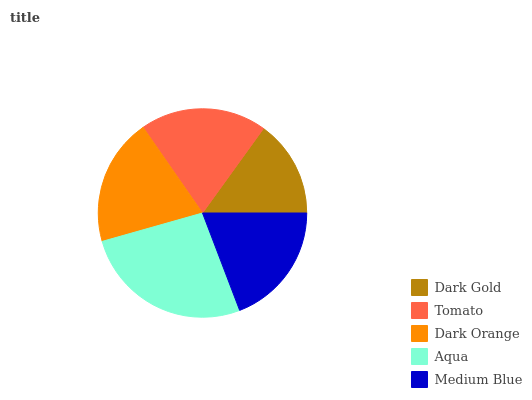Is Dark Gold the minimum?
Answer yes or no. Yes. Is Aqua the maximum?
Answer yes or no. Yes. Is Tomato the minimum?
Answer yes or no. No. Is Tomato the maximum?
Answer yes or no. No. Is Tomato greater than Dark Gold?
Answer yes or no. Yes. Is Dark Gold less than Tomato?
Answer yes or no. Yes. Is Dark Gold greater than Tomato?
Answer yes or no. No. Is Tomato less than Dark Gold?
Answer yes or no. No. Is Tomato the high median?
Answer yes or no. Yes. Is Tomato the low median?
Answer yes or no. Yes. Is Dark Orange the high median?
Answer yes or no. No. Is Dark Orange the low median?
Answer yes or no. No. 